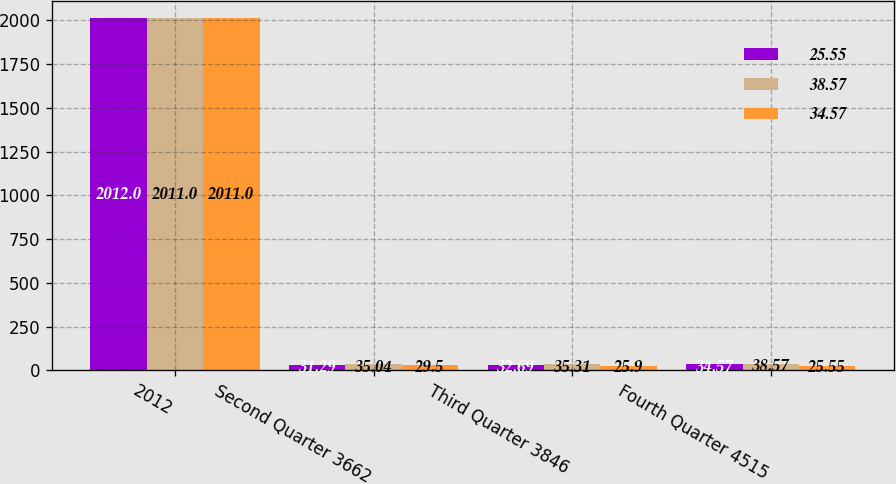Convert chart. <chart><loc_0><loc_0><loc_500><loc_500><stacked_bar_chart><ecel><fcel>2012<fcel>Second Quarter 3662<fcel>Third Quarter 3846<fcel>Fourth Quarter 4515<nl><fcel>25.55<fcel>2012<fcel>31.29<fcel>32.69<fcel>34.57<nl><fcel>38.57<fcel>2011<fcel>35.04<fcel>35.31<fcel>38.57<nl><fcel>34.57<fcel>2011<fcel>29.5<fcel>25.9<fcel>25.55<nl></chart> 